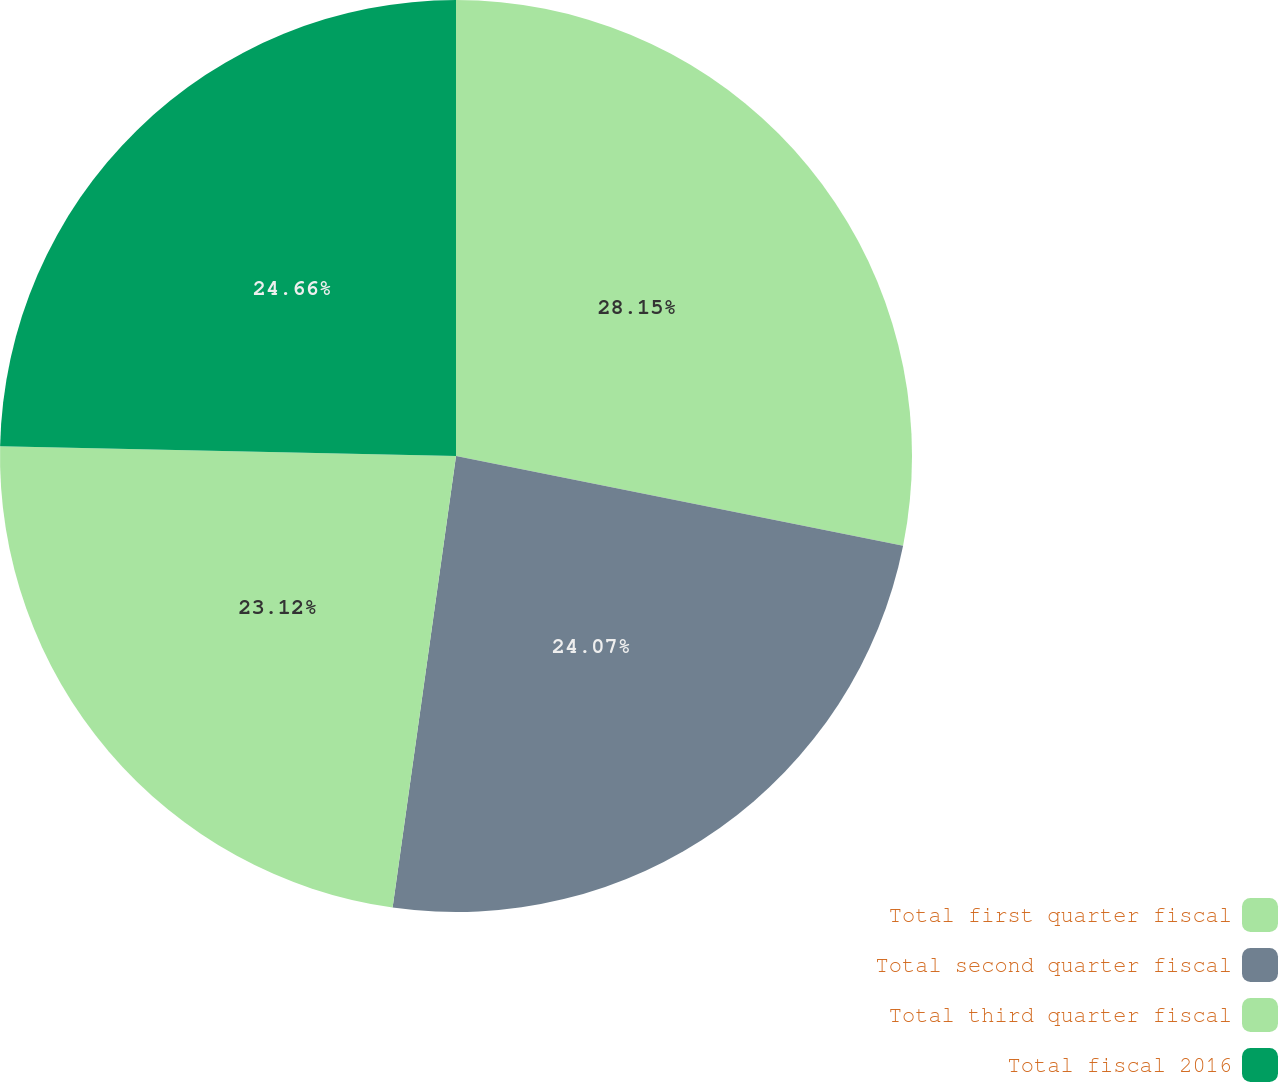Convert chart to OTSL. <chart><loc_0><loc_0><loc_500><loc_500><pie_chart><fcel>Total first quarter fiscal<fcel>Total second quarter fiscal<fcel>Total third quarter fiscal<fcel>Total fiscal 2016<nl><fcel>28.15%<fcel>24.07%<fcel>23.12%<fcel>24.66%<nl></chart> 